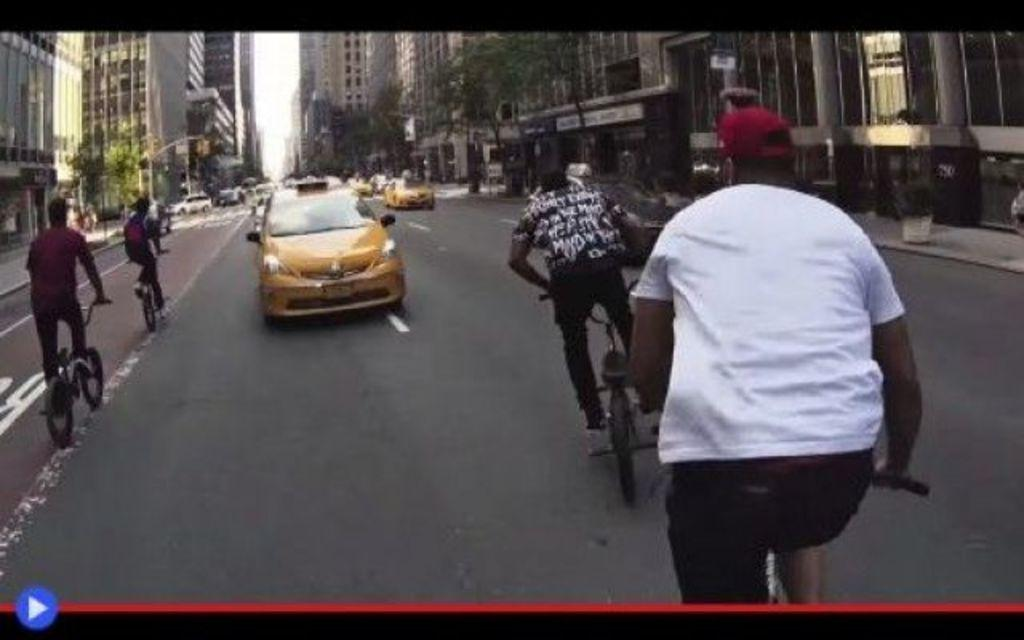What type of structures can be seen in the image? There are buildings in the image. What other natural elements are present in the image? There are trees in the image. What mode of transportation can be seen in the image? There are cars in the image. What activity are some people engaged in within the image? There are people riding bicycles in the image. Can you see the roots of the trees in the image? There is no mention of tree roots in the provided facts, so we cannot determine if they are visible in the image. What type of brush is being used by the people in the image? There is no brush present in the image; people are riding bicycles. 